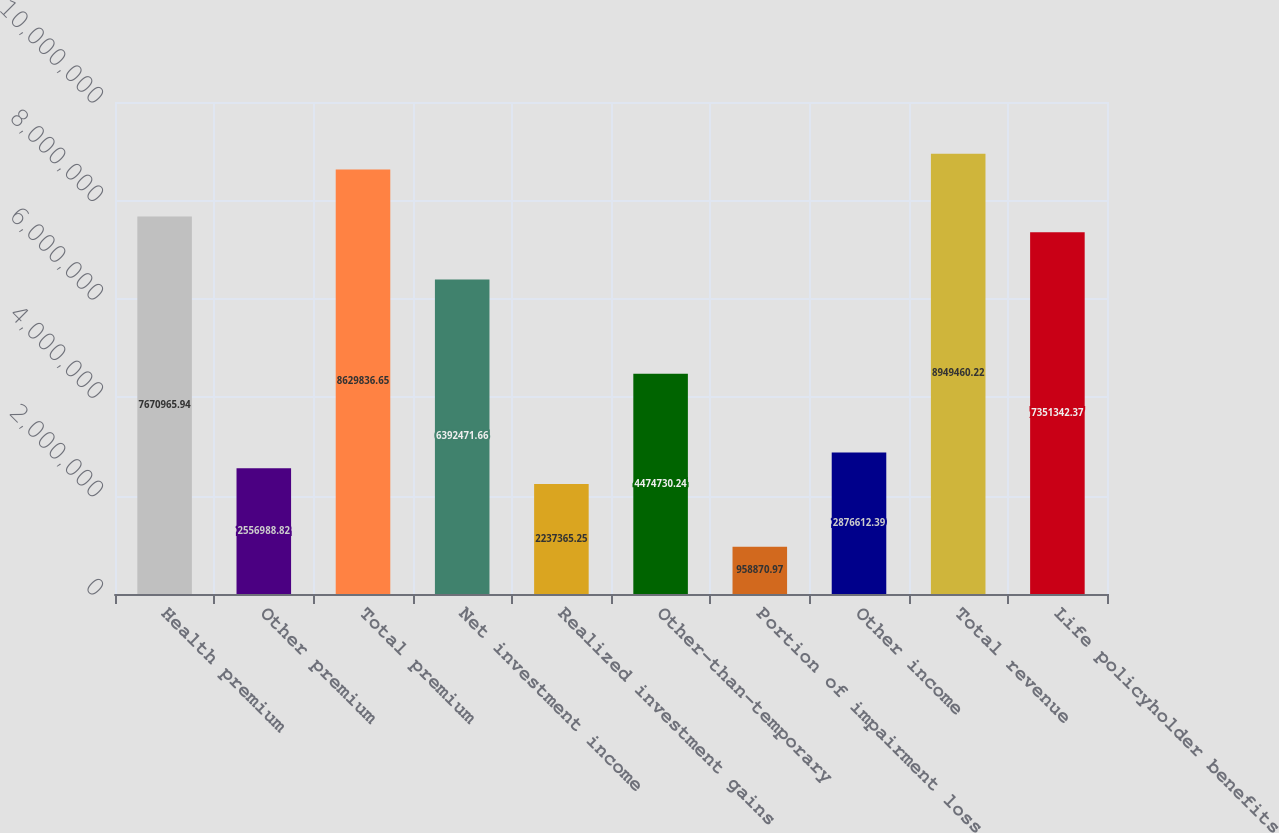Convert chart to OTSL. <chart><loc_0><loc_0><loc_500><loc_500><bar_chart><fcel>Health premium<fcel>Other premium<fcel>Total premium<fcel>Net investment income<fcel>Realized investment gains<fcel>Other-than-temporary<fcel>Portion of impairment loss<fcel>Other income<fcel>Total revenue<fcel>Life policyholder benefits<nl><fcel>7.67097e+06<fcel>2.55699e+06<fcel>8.62984e+06<fcel>6.39247e+06<fcel>2.23737e+06<fcel>4.47473e+06<fcel>958871<fcel>2.87661e+06<fcel>8.94946e+06<fcel>7.35134e+06<nl></chart> 